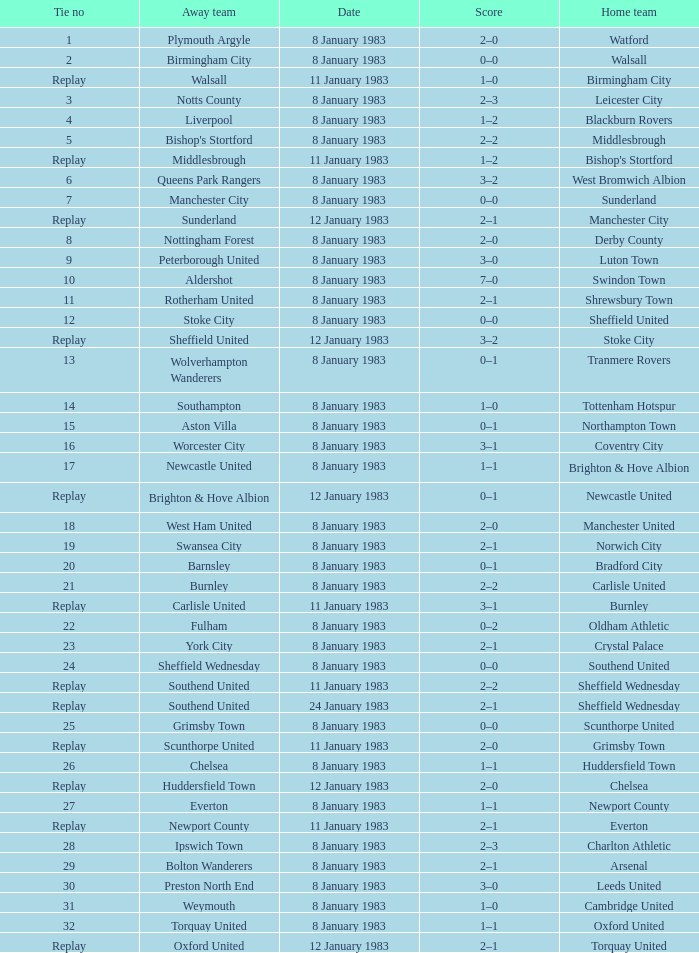What was the final score for the tie where Leeds United was the home team? 3–0. 